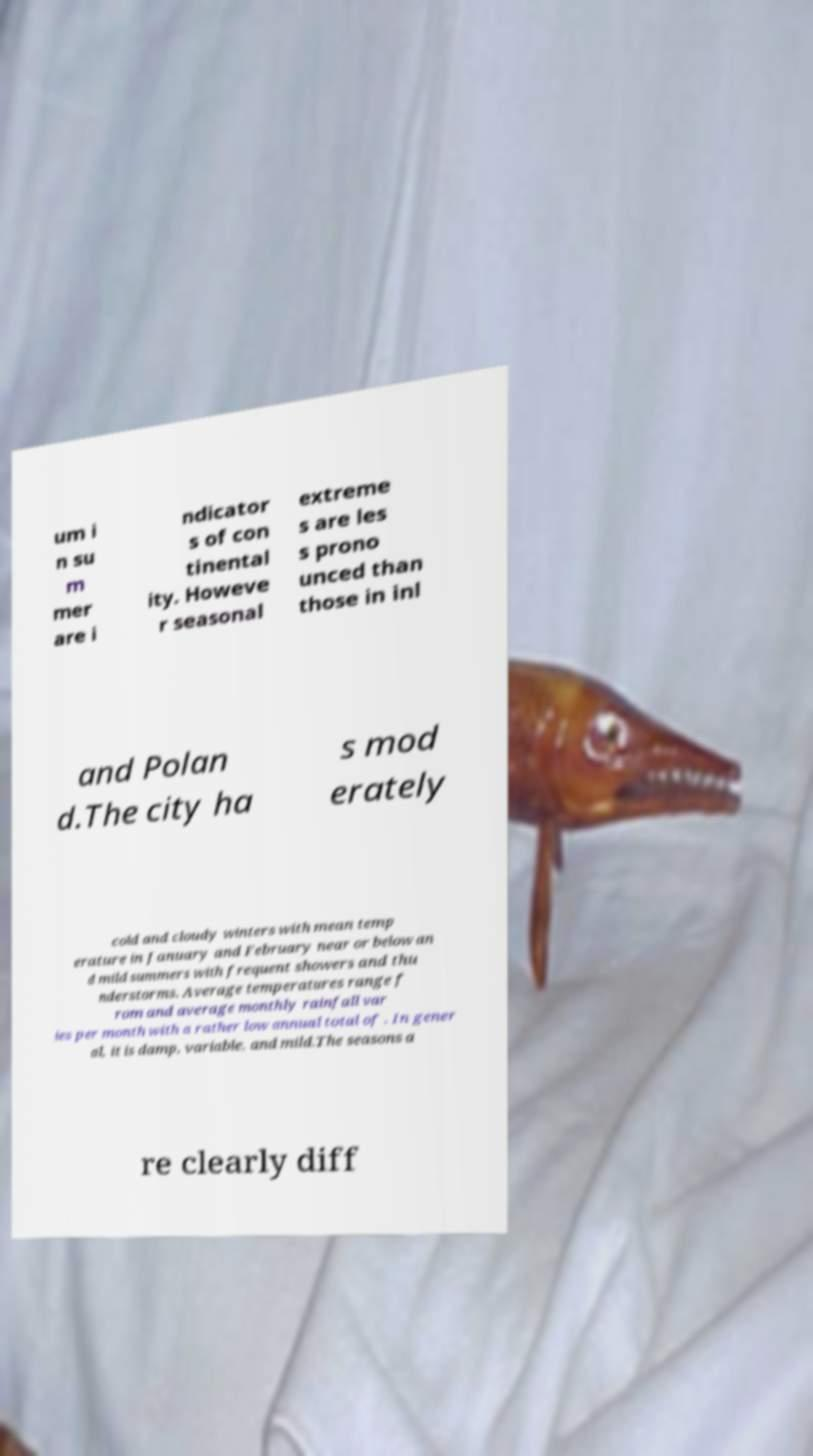I need the written content from this picture converted into text. Can you do that? um i n su m mer are i ndicator s of con tinental ity. Howeve r seasonal extreme s are les s prono unced than those in inl and Polan d.The city ha s mod erately cold and cloudy winters with mean temp erature in January and February near or below an d mild summers with frequent showers and thu nderstorms. Average temperatures range f rom and average monthly rainfall var ies per month with a rather low annual total of . In gener al, it is damp, variable, and mild.The seasons a re clearly diff 